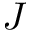Convert formula to latex. <formula><loc_0><loc_0><loc_500><loc_500>J</formula> 